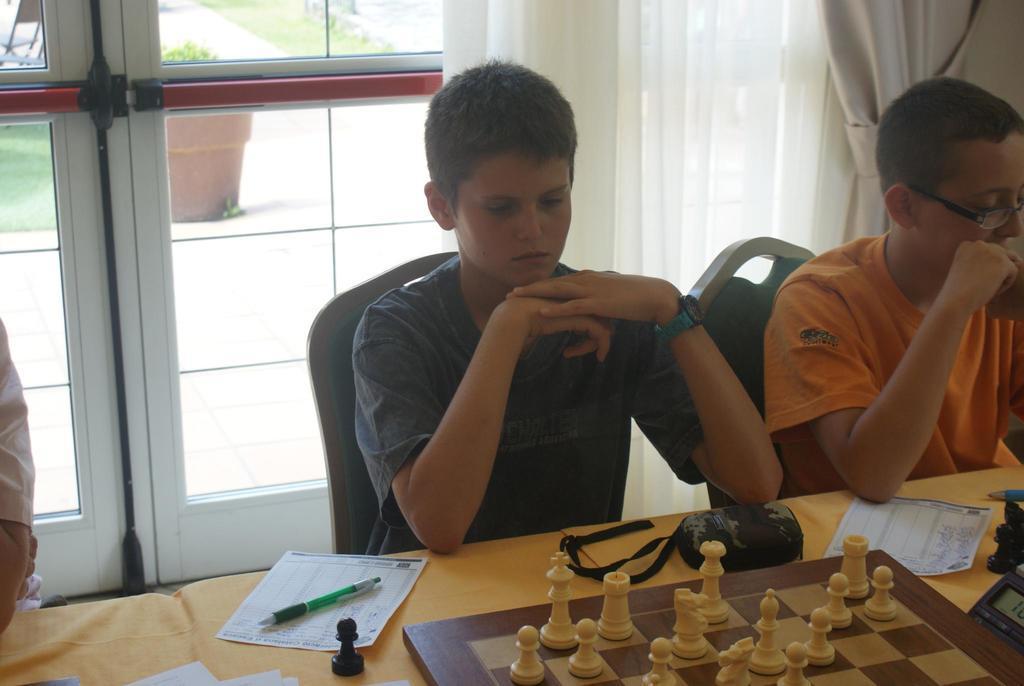How would you summarize this image in a sentence or two? in this image i can see a chess board, a paper note and a pen on the table and two men are sitting on the chairs. the man at the right is wearing orange t shirt. behind them there is white curtain. 